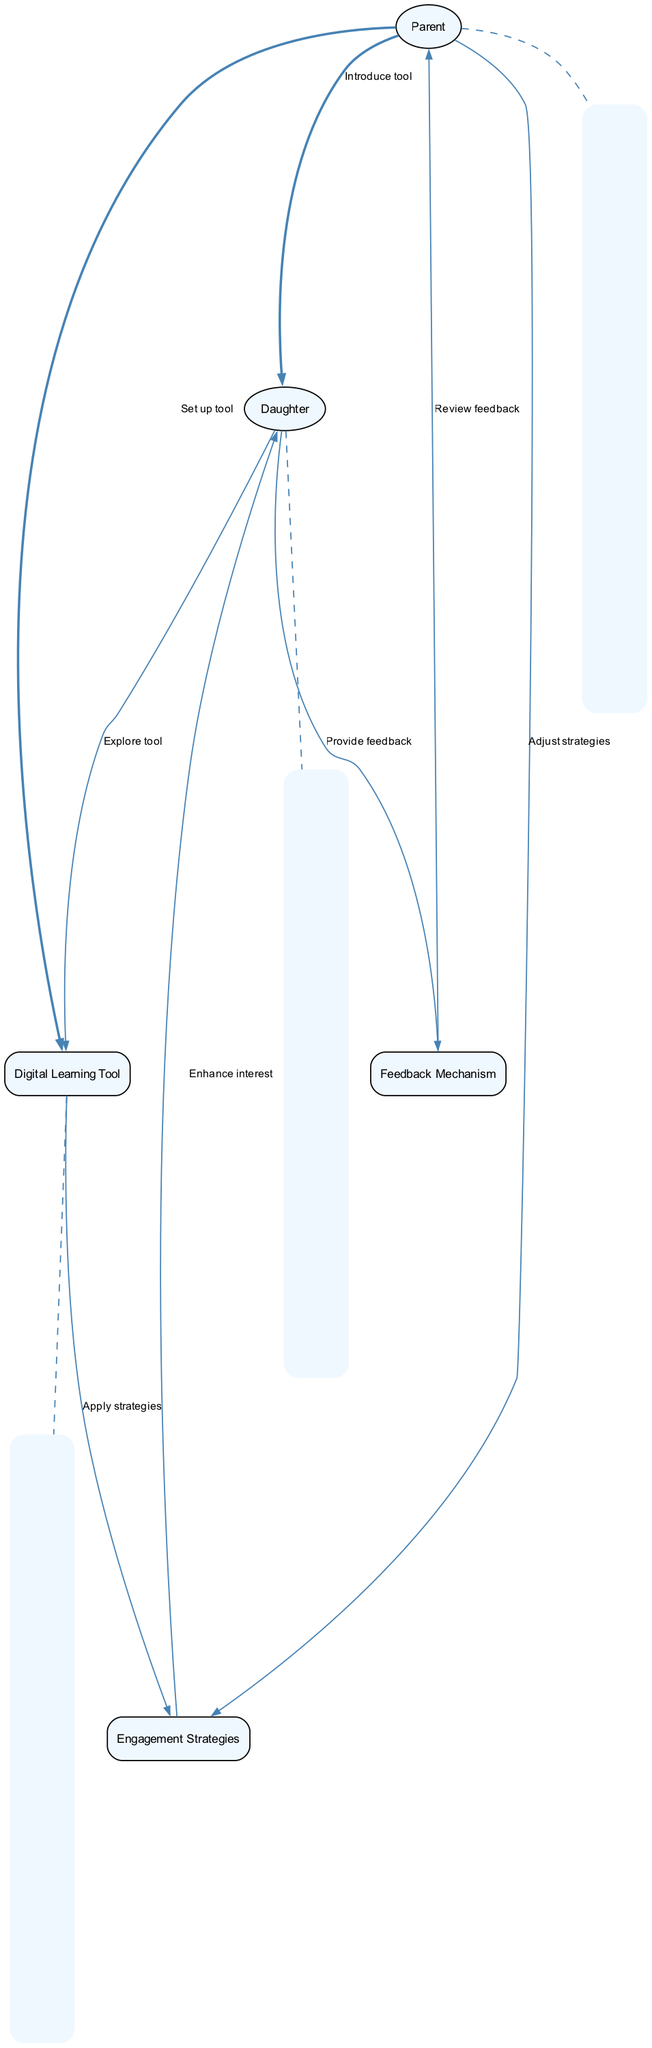What is the role of the "Parent" in the diagram? The "Parent" is the mother providing guidance to her daughter by setting up the digital learning tool and introducing it to her.
Answer: Guidance provider How many main elements are there in the diagram? The main elements consist of five distinct components: Parent, Daughter, Digital Learning Tool, Engagement Strategies, and Feedback Mechanism.
Answer: Five What action does the "Daughter" take after exploring the tool? After exploring the tool, the "Daughter" provides feedback to the Feedback Mechanism, indicating her experience and thoughts on the tool.
Answer: Provide feedback Which element directly communicates with "Engagement Strategies"? The "Digital Learning Tool" communicates directly with "Engagement Strategies" to apply the necessary techniques to enhance learning engagement.
Answer: Digital Learning Tool What is the first action taken by the "Parent" in the sequence? The first action taken by the "Parent" is to set up the digital learning tool for use.
Answer: Set up tool What feedback does the "Parent" receive from the "Feedback Mechanism"? The "Parent" receives insight from the "Feedback Mechanism" after the "Daughter" provides her feedback on the digital learning tool's effectiveness.
Answer: Review feedback What does the "Daughter" receive from "Engagement Strategies"? The "Daughter" receives enhanced interest in learning as a result of applying the engagement strategies put in place via the digital learning tool.
Answer: Enhance interest What is the overall goal of the interactions in the diagram? The overall goal is to enhance the daughter's engagement in learning through the effective use of a digital learning tool and strategies.
Answer: Enhance engagement Which process is responsible for adjusting the strategies after feedback is reviewed? The "Parent" is responsible for adjusting the Engagement Strategies based on the feedback received from the "Daughter" via the Feedback Mechanism.
Answer: Adjust strategies 